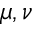Convert formula to latex. <formula><loc_0><loc_0><loc_500><loc_500>\mu , \nu</formula> 